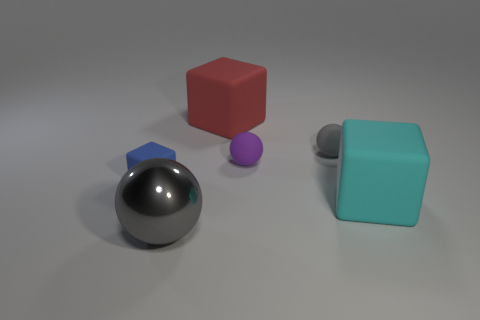What number of large cyan blocks have the same material as the tiny blue block?
Your response must be concise. 1. Do the rubber object on the right side of the small gray object and the metallic object have the same shape?
Ensure brevity in your answer.  No. There is a large rubber object in front of the small blue matte cube; what is its shape?
Provide a short and direct response. Cube. There is a matte thing that is the same color as the metal sphere; what is its size?
Your answer should be compact. Small. What is the material of the big red block?
Make the answer very short. Rubber. There is a block that is the same size as the purple matte object; what color is it?
Give a very brief answer. Blue. There is a tiny matte object that is the same color as the large metal object; what shape is it?
Your answer should be very brief. Sphere. Does the tiny blue object have the same shape as the large red rubber object?
Make the answer very short. Yes. There is a large thing that is left of the large cyan rubber cube and in front of the tiny gray thing; what is its material?
Keep it short and to the point. Metal. What size is the cyan rubber cube?
Make the answer very short. Large. 